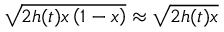<formula> <loc_0><loc_0><loc_500><loc_500>\sqrt { 2 h ( t ) x \left ( 1 - x \right ) } \approx \sqrt { 2 h ( t ) x }</formula> 